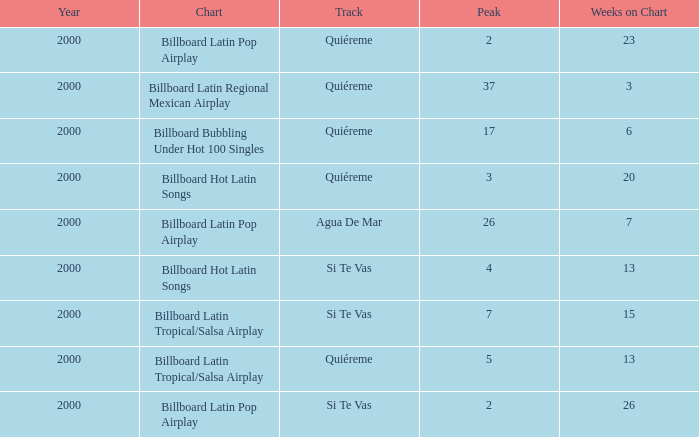Name the least weeks for year less than 2000 None. 